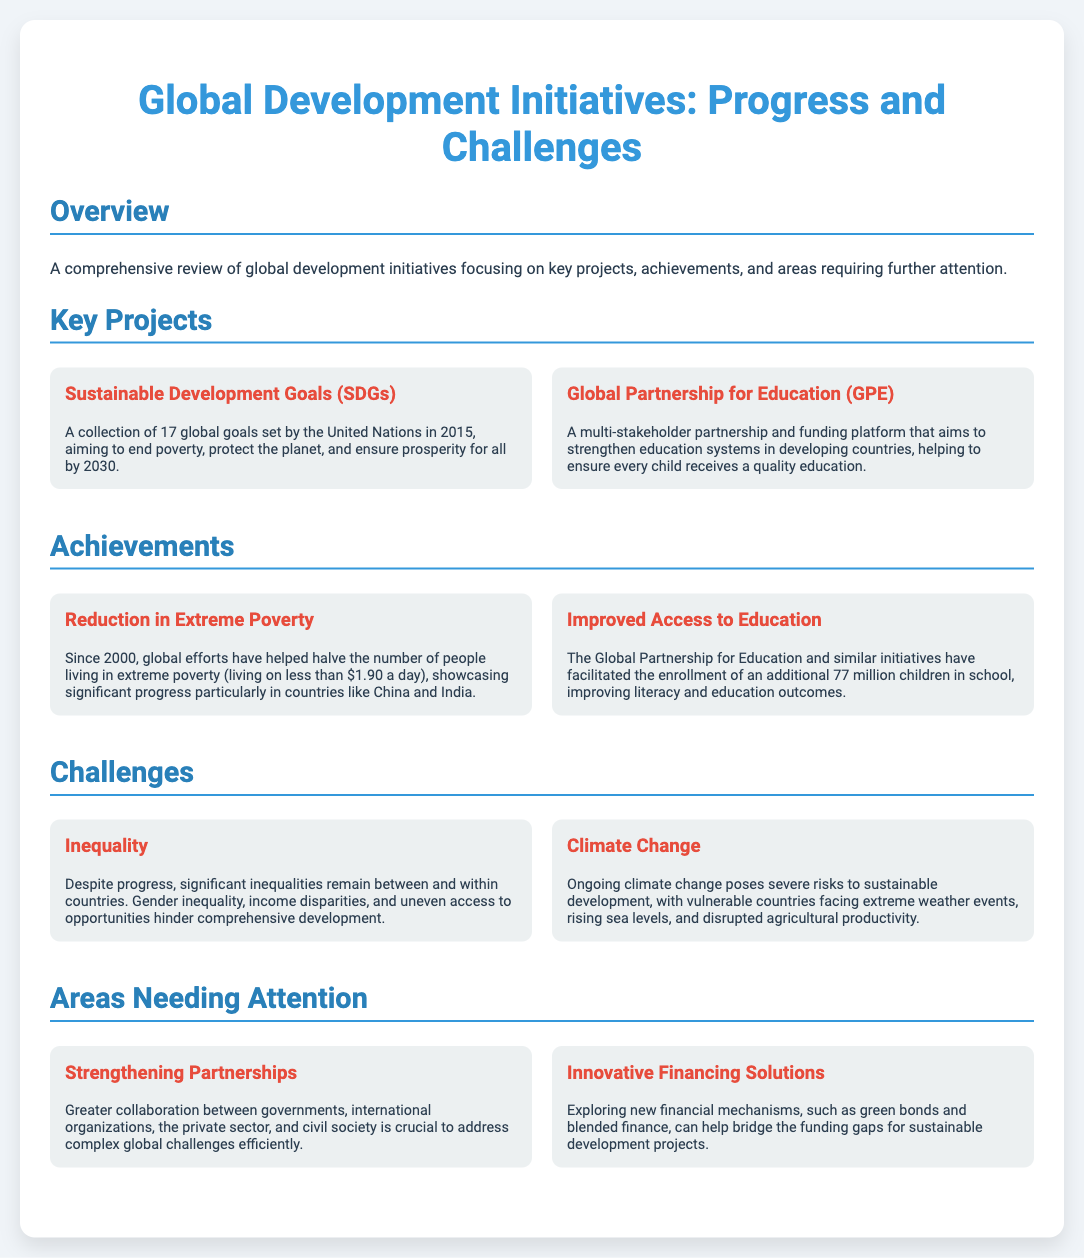What are the Sustainable Development Goals? The Sustainable Development Goals are a collection of 17 global goals set by the United Nations in 2015, aiming to end poverty, protect the planet, and ensure prosperity for all by 2030.
Answer: 17 global goals What does the Global Partnership for Education aim to do? The Global Partnership for Education aims to strengthen education systems in developing countries, helping to ensure every child receives a quality education.
Answer: Strengthen education systems What has been one of the notable achievements since 2000? Since 2000, global efforts have halved the number of people living in extreme poverty, particularly in countries like China and India.
Answer: Halved extreme poverty How many children have been enrolled in school through education initiatives? The Global Partnership for Education and similar initiatives have facilitated the enrollment of an additional 77 million children in school, improving literacy and education outcomes.
Answer: 77 million children What is one of the challenges faced in global development? Despite progress, significant inequalities remain between and within countries, including gender inequality and income disparities.
Answer: Inequality What are two areas requiring attention mentioned in the document? Two areas needing attention are strengthening partnerships and exploring innovative financing solutions to bridge funding gaps.
Answer: Strengthening partnerships and innovative financing solutions Why is collaboration important according to the document? Greater collaboration between governments, international organizations, the private sector, and civil society is crucial to address complex global challenges efficiently.
Answer: To address complex challenges efficiently What type of new financial mechanisms are suggested for sustainable development projects? The document suggests exploring new financial mechanisms such as green bonds and blended finance to help bridge the funding gaps for sustainable development projects.
Answer: Green bonds and blended finance 